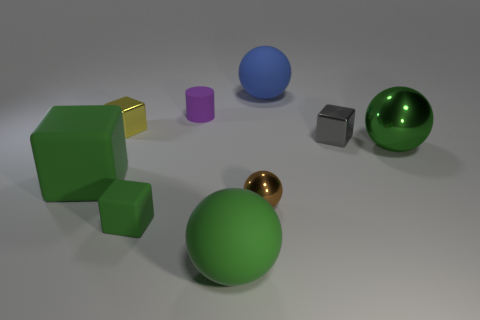What might be the purpose of arranging these objects? This arrangement could serve several purposes, such as visual representation for 3D modeling, a physical simulation, or simply as an artistic composition that plays with shape, color, and space. Is there anything about the lighting in this scene? The scene is lit from above, casting soft shadows directly underneath the objects, which suggests a single, broad light source, providing a calm and even illumination which is commonly used in product visualization or graphic design layouts. 